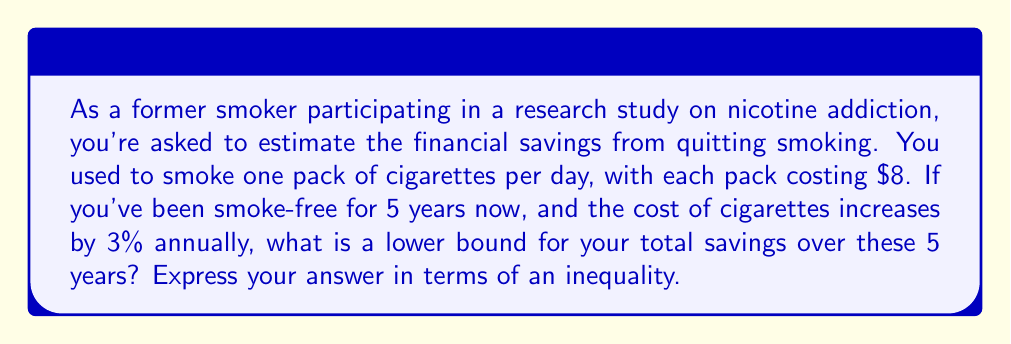Can you answer this question? Let's approach this step-by-step:

1) First, let's calculate the base cost per year:
   $8 per pack × 365 days = $2,920 per year

2) Now, we need to account for the 3% annual increase in cigarette costs. Let's calculate the cost for each year:

   Year 1: $2,920
   Year 2: $2,920 × 1.03 = $3,007.60
   Year 3: $3,007.60 × 1.03 = $3,097.83
   Year 4: $3,097.83 × 1.03 = $3,190.76
   Year 5: $3,190.76 × 1.03 = $3,286.49

3) The total savings is the sum of these amounts:
   $2,920 + $3,007.60 + $3,097.83 + $3,190.76 + $3,286.49 = $15,502.68

4) However, the question asks for a lower bound. We can use the fact that:

   $$(1+r)^n \geq 1 + nr$$

   Where $r$ is the growth rate and $n$ is the number of periods.

5) Applying this to our scenario:
   $$(1.03)^4 \geq 1 + 4(0.03) = 1.12$$

6) This means our total savings is at least:
   $$2,920 × 5 × 1.12 = $16,352$$

Therefore, we can say that the savings is greater than or equal to $16,352.
Answer: Savings $\geq \$16,352$ 